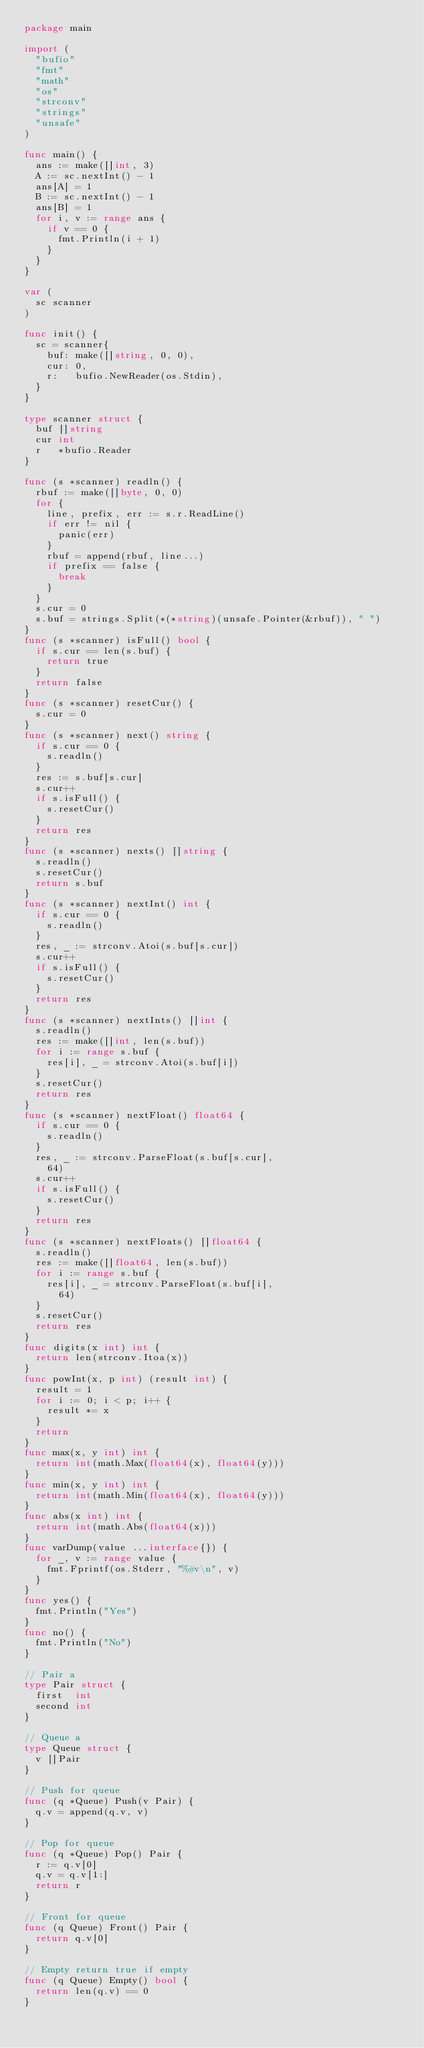<code> <loc_0><loc_0><loc_500><loc_500><_Go_>package main

import (
	"bufio"
	"fmt"
	"math"
	"os"
	"strconv"
	"strings"
	"unsafe"
)

func main() {
	ans := make([]int, 3)
	A := sc.nextInt() - 1
	ans[A] = 1
	B := sc.nextInt() - 1
	ans[B] = 1
	for i, v := range ans {
		if v == 0 {
			fmt.Println(i + 1)
		}
	}
}

var (
	sc scanner
)

func init() {
	sc = scanner{
		buf: make([]string, 0, 0),
		cur: 0,
		r:   bufio.NewReader(os.Stdin),
	}
}

type scanner struct {
	buf []string
	cur int
	r   *bufio.Reader
}

func (s *scanner) readln() {
	rbuf := make([]byte, 0, 0)
	for {
		line, prefix, err := s.r.ReadLine()
		if err != nil {
			panic(err)
		}
		rbuf = append(rbuf, line...)
		if prefix == false {
			break
		}
	}
	s.cur = 0
	s.buf = strings.Split(*(*string)(unsafe.Pointer(&rbuf)), " ")
}
func (s *scanner) isFull() bool {
	if s.cur == len(s.buf) {
		return true
	}
	return false
}
func (s *scanner) resetCur() {
	s.cur = 0
}
func (s *scanner) next() string {
	if s.cur == 0 {
		s.readln()
	}
	res := s.buf[s.cur]
	s.cur++
	if s.isFull() {
		s.resetCur()
	}
	return res
}
func (s *scanner) nexts() []string {
	s.readln()
	s.resetCur()
	return s.buf
}
func (s *scanner) nextInt() int {
	if s.cur == 0 {
		s.readln()
	}
	res, _ := strconv.Atoi(s.buf[s.cur])
	s.cur++
	if s.isFull() {
		s.resetCur()
	}
	return res
}
func (s *scanner) nextInts() []int {
	s.readln()
	res := make([]int, len(s.buf))
	for i := range s.buf {
		res[i], _ = strconv.Atoi(s.buf[i])
	}
	s.resetCur()
	return res
}
func (s *scanner) nextFloat() float64 {
	if s.cur == 0 {
		s.readln()
	}
	res, _ := strconv.ParseFloat(s.buf[s.cur],
		64)
	s.cur++
	if s.isFull() {
		s.resetCur()
	}
	return res
}
func (s *scanner) nextFloats() []float64 {
	s.readln()
	res := make([]float64, len(s.buf))
	for i := range s.buf {
		res[i], _ = strconv.ParseFloat(s.buf[i],
			64)
	}
	s.resetCur()
	return res
}
func digits(x int) int {
	return len(strconv.Itoa(x))
}
func powInt(x, p int) (result int) {
	result = 1
	for i := 0; i < p; i++ {
		result *= x
	}
	return
}
func max(x, y int) int {
	return int(math.Max(float64(x), float64(y)))
}
func min(x, y int) int {
	return int(math.Min(float64(x), float64(y)))
}
func abs(x int) int {
	return int(math.Abs(float64(x)))
}
func varDump(value ...interface{}) {
	for _, v := range value {
		fmt.Fprintf(os.Stderr, "%#v\n", v)
	}
}
func yes() {
	fmt.Println("Yes")
}
func no() {
	fmt.Println("No")
}

// Pair a
type Pair struct {
	first  int
	second int
}

// Queue a
type Queue struct {
	v []Pair
}

// Push for queue
func (q *Queue) Push(v Pair) {
	q.v = append(q.v, v)
}

// Pop for queue
func (q *Queue) Pop() Pair {
	r := q.v[0]
	q.v = q.v[1:]
	return r
}

// Front for queue
func (q Queue) Front() Pair {
	return q.v[0]
}

// Empty return true if empty
func (q Queue) Empty() bool {
	return len(q.v) == 0
}
</code> 